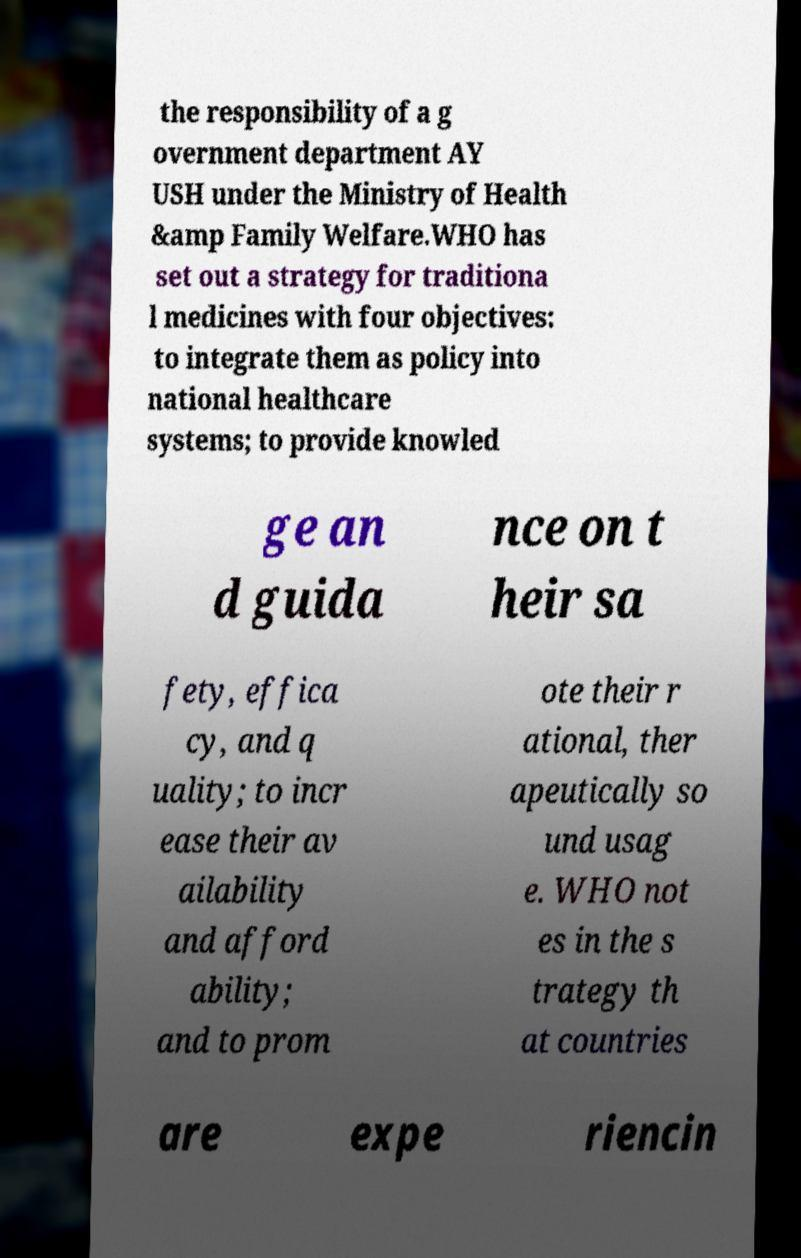Please read and relay the text visible in this image. What does it say? the responsibility of a g overnment department AY USH under the Ministry of Health &amp Family Welfare.WHO has set out a strategy for traditiona l medicines with four objectives: to integrate them as policy into national healthcare systems; to provide knowled ge an d guida nce on t heir sa fety, effica cy, and q uality; to incr ease their av ailability and afford ability; and to prom ote their r ational, ther apeutically so und usag e. WHO not es in the s trategy th at countries are expe riencin 